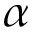<formula> <loc_0><loc_0><loc_500><loc_500>\alpha</formula> 